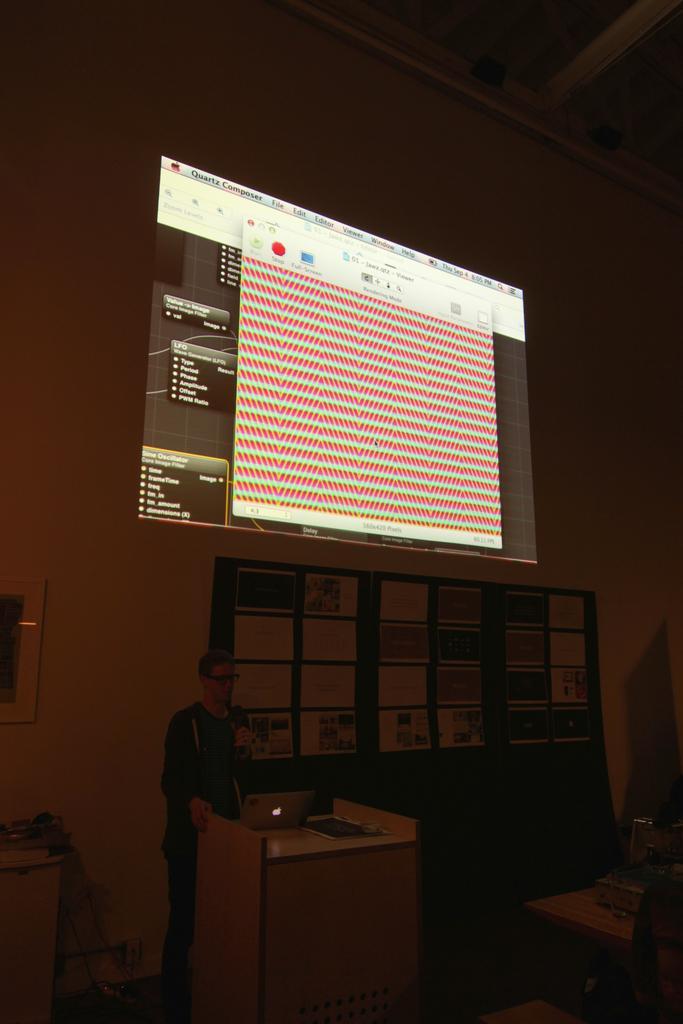Could you give a brief overview of what you see in this image? In this image I can see a person holding a mic and the person is standing in front of the podium. On the table there is a laptop,book. At the back side we can see a screen. 